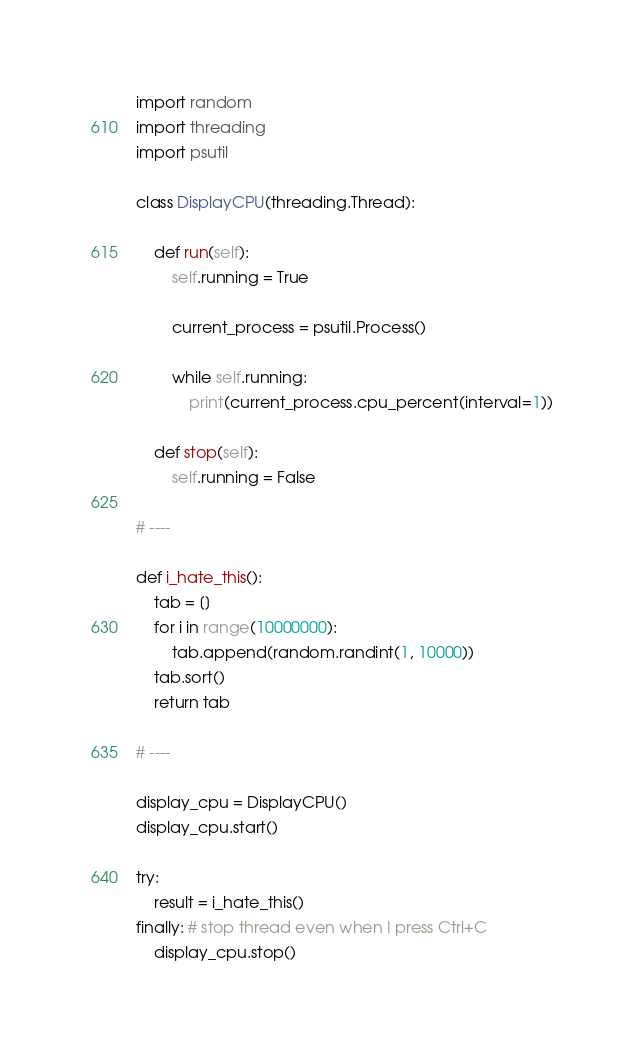Convert code to text. <code><loc_0><loc_0><loc_500><loc_500><_Python_>import random
import threading
import psutil

class DisplayCPU(threading.Thread):

    def run(self):
        self.running = True
        
        current_process = psutil.Process()

        while self.running:
            print(current_process.cpu_percent(interval=1))

    def stop(self):
        self.running = False
    
# ----

def i_hate_this():
    tab = []
    for i in range(10000000):
        tab.append(random.randint(1, 10000))
    tab.sort()
    return tab

# ----

display_cpu = DisplayCPU()
display_cpu.start()

try:
    result = i_hate_this()
finally: # stop thread even when I press Ctrl+C
    display_cpu.stop()


</code> 